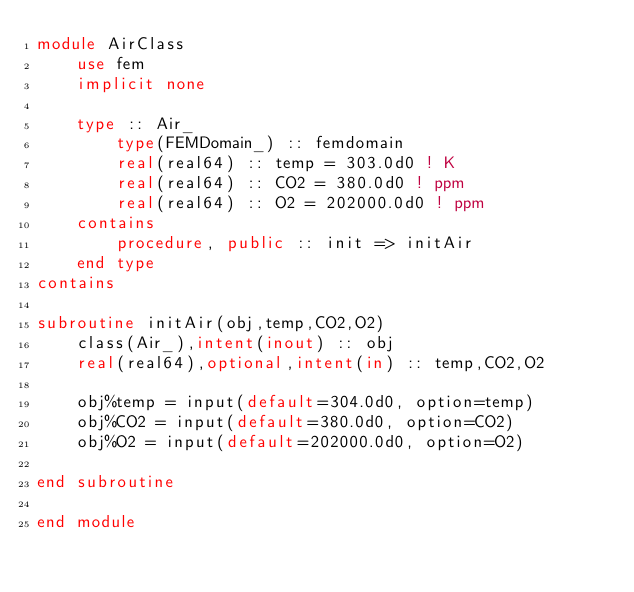Convert code to text. <code><loc_0><loc_0><loc_500><loc_500><_FORTRAN_>module AirClass
    use fem
    implicit none

    type :: Air_
        type(FEMDomain_) :: femdomain
        real(real64) :: temp = 303.0d0 ! K
        real(real64) :: CO2 = 380.0d0 ! ppm
        real(real64) :: O2 = 202000.0d0 ! ppm
    contains
        procedure, public :: init => initAir
    end type
contains

subroutine initAir(obj,temp,CO2,O2)
    class(Air_),intent(inout) :: obj
    real(real64),optional,intent(in) :: temp,CO2,O2

    obj%temp = input(default=304.0d0, option=temp)
    obj%CO2 = input(default=380.0d0, option=CO2)
    obj%O2 = input(default=202000.0d0, option=O2)

end subroutine

end module </code> 